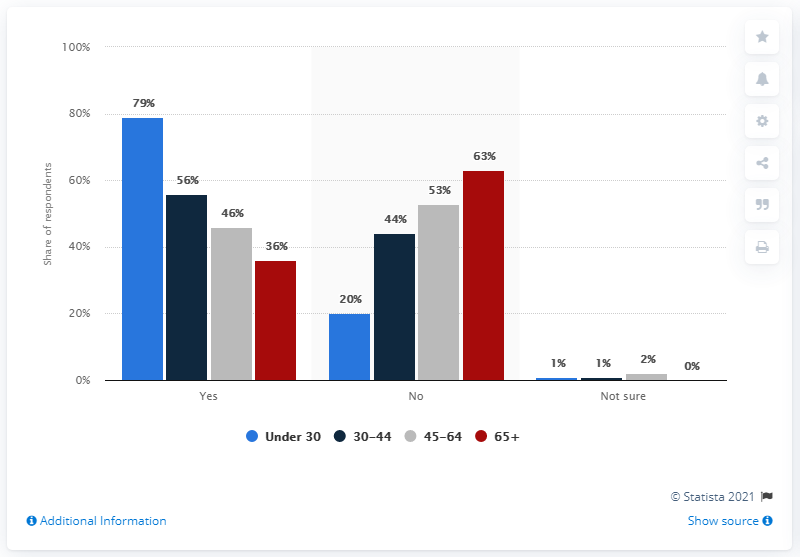Point out several critical features in this image. The difference between the percentage of respondents in the 30-44 age groups who responded "YES" and "NO" is 12%. Out of the respondents in the 30-44 age group, 56% responded as 'YES'. 